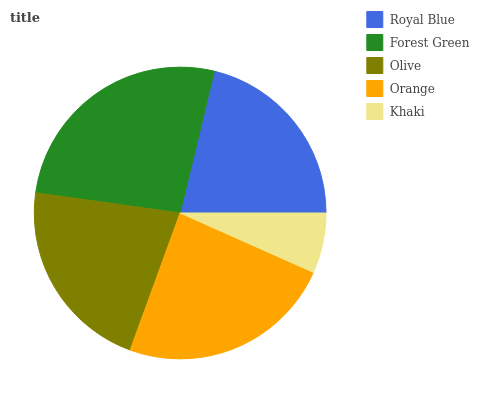Is Khaki the minimum?
Answer yes or no. Yes. Is Forest Green the maximum?
Answer yes or no. Yes. Is Olive the minimum?
Answer yes or no. No. Is Olive the maximum?
Answer yes or no. No. Is Forest Green greater than Olive?
Answer yes or no. Yes. Is Olive less than Forest Green?
Answer yes or no. Yes. Is Olive greater than Forest Green?
Answer yes or no. No. Is Forest Green less than Olive?
Answer yes or no. No. Is Olive the high median?
Answer yes or no. Yes. Is Olive the low median?
Answer yes or no. Yes. Is Royal Blue the high median?
Answer yes or no. No. Is Royal Blue the low median?
Answer yes or no. No. 